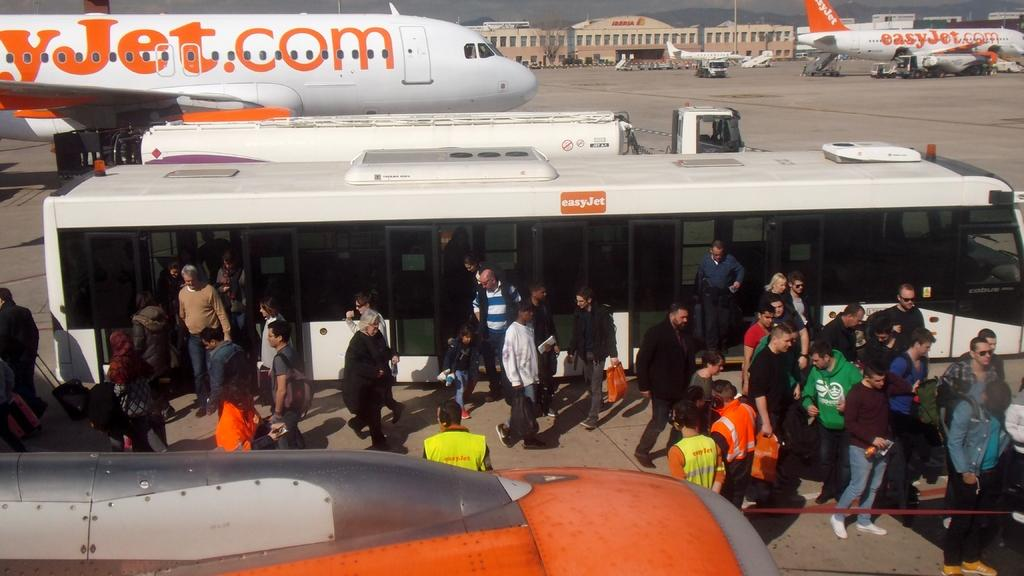How many people are in the image? There is a group of people in the image. What are the people standing near in the image? The people are standing near a bus in the image. What can be seen in the background of the image? In the background, there are airplanes on the runway, vehicles, poles, and the sky. What type of location is depicted in the image? The image shows an airport. Where is the throne located in the image? There is no throne present in the image. Can you describe the gate in the image? There is no gate present in the image. 